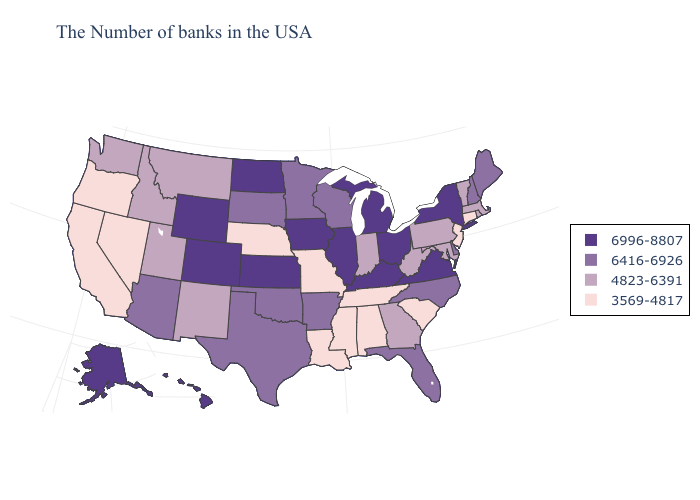Does Indiana have the highest value in the USA?
Be succinct. No. Among the states that border Massachusetts , does New York have the highest value?
Keep it brief. Yes. Does Missouri have a lower value than Mississippi?
Answer briefly. No. What is the value of Indiana?
Quick response, please. 4823-6391. Name the states that have a value in the range 3569-4817?
Short answer required. Connecticut, New Jersey, South Carolina, Alabama, Tennessee, Mississippi, Louisiana, Missouri, Nebraska, Nevada, California, Oregon. What is the value of Mississippi?
Keep it brief. 3569-4817. Name the states that have a value in the range 4823-6391?
Write a very short answer. Massachusetts, Rhode Island, Vermont, Maryland, Pennsylvania, West Virginia, Georgia, Indiana, New Mexico, Utah, Montana, Idaho, Washington. Among the states that border Florida , which have the lowest value?
Give a very brief answer. Alabama. Does the map have missing data?
Give a very brief answer. No. Among the states that border Montana , which have the lowest value?
Write a very short answer. Idaho. Name the states that have a value in the range 4823-6391?
Short answer required. Massachusetts, Rhode Island, Vermont, Maryland, Pennsylvania, West Virginia, Georgia, Indiana, New Mexico, Utah, Montana, Idaho, Washington. What is the highest value in states that border Alabama?
Quick response, please. 6416-6926. Among the states that border Massachusetts , does New York have the lowest value?
Write a very short answer. No. What is the value of Virginia?
Write a very short answer. 6996-8807. Among the states that border Pennsylvania , which have the lowest value?
Write a very short answer. New Jersey. 